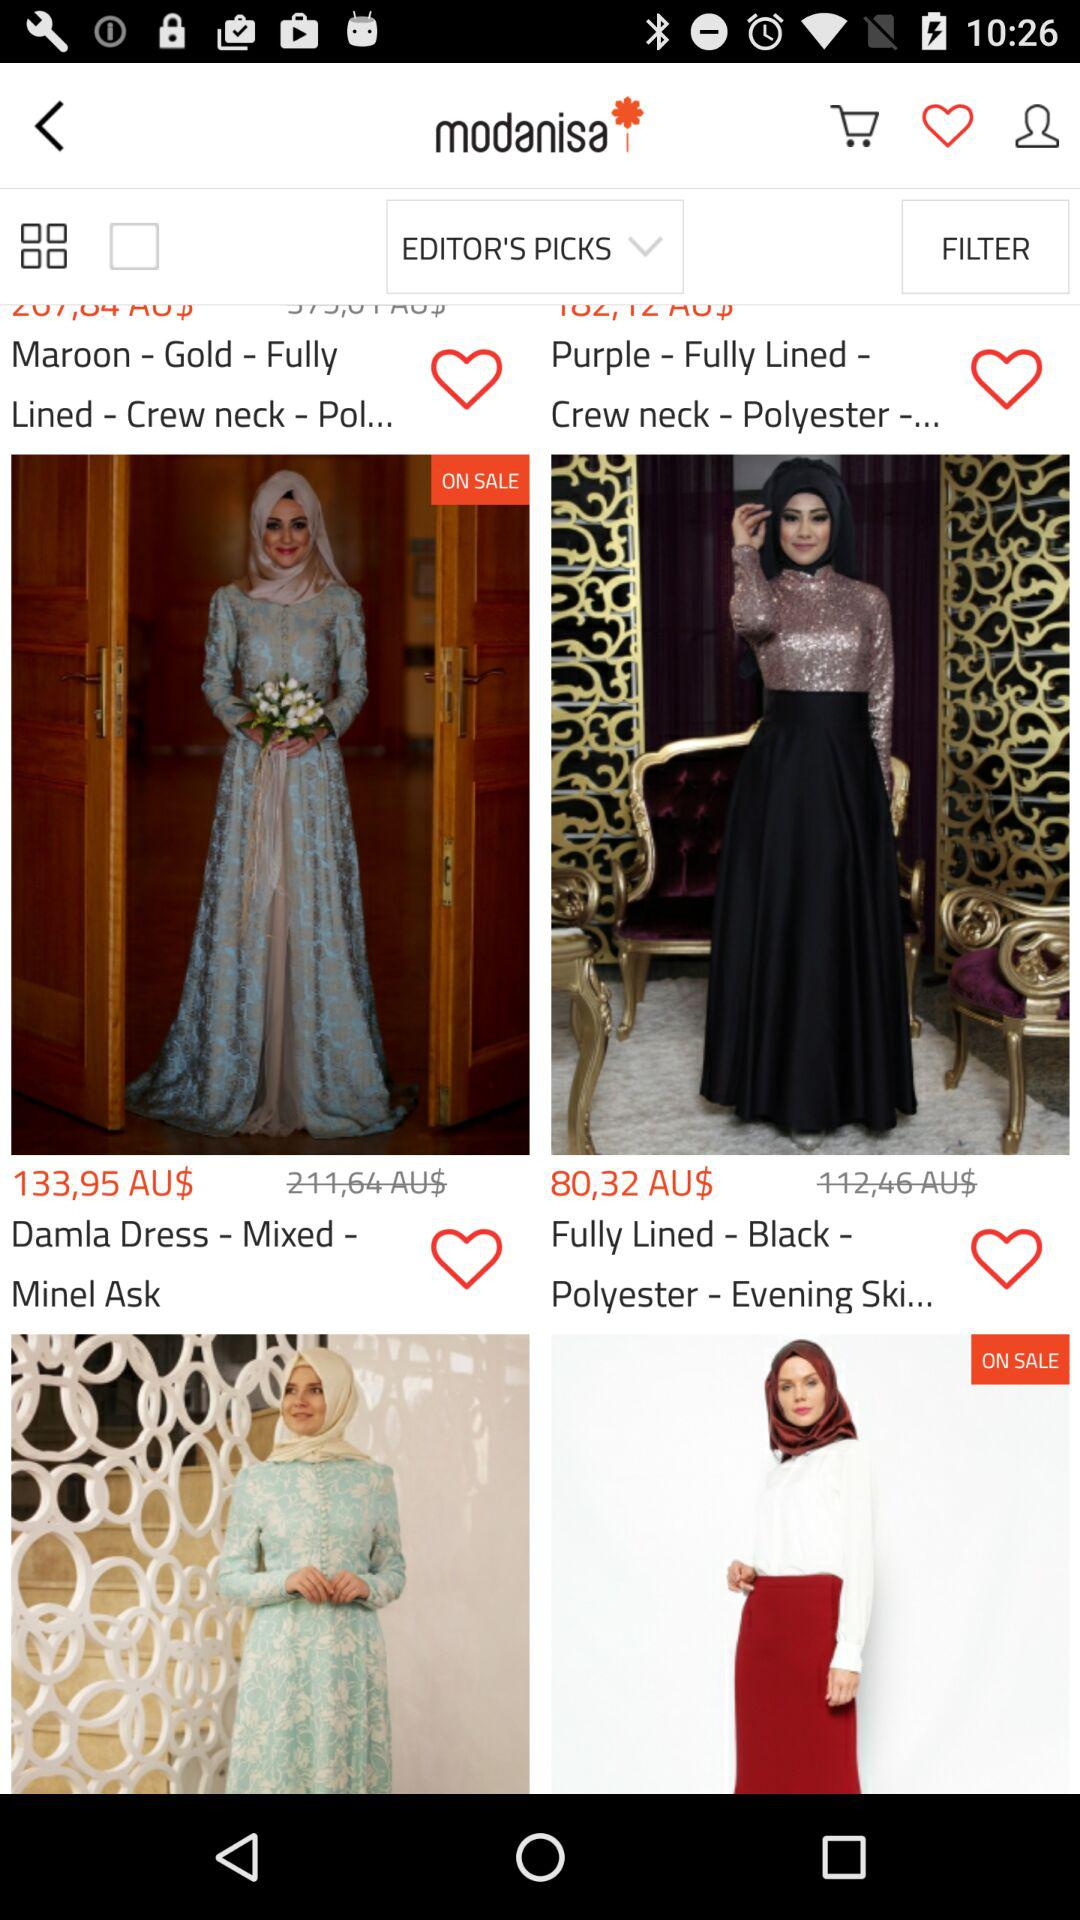What neck design is available for the maroon-gold dress? The neck design available for the maroon-gold dress is "Crew neck". 